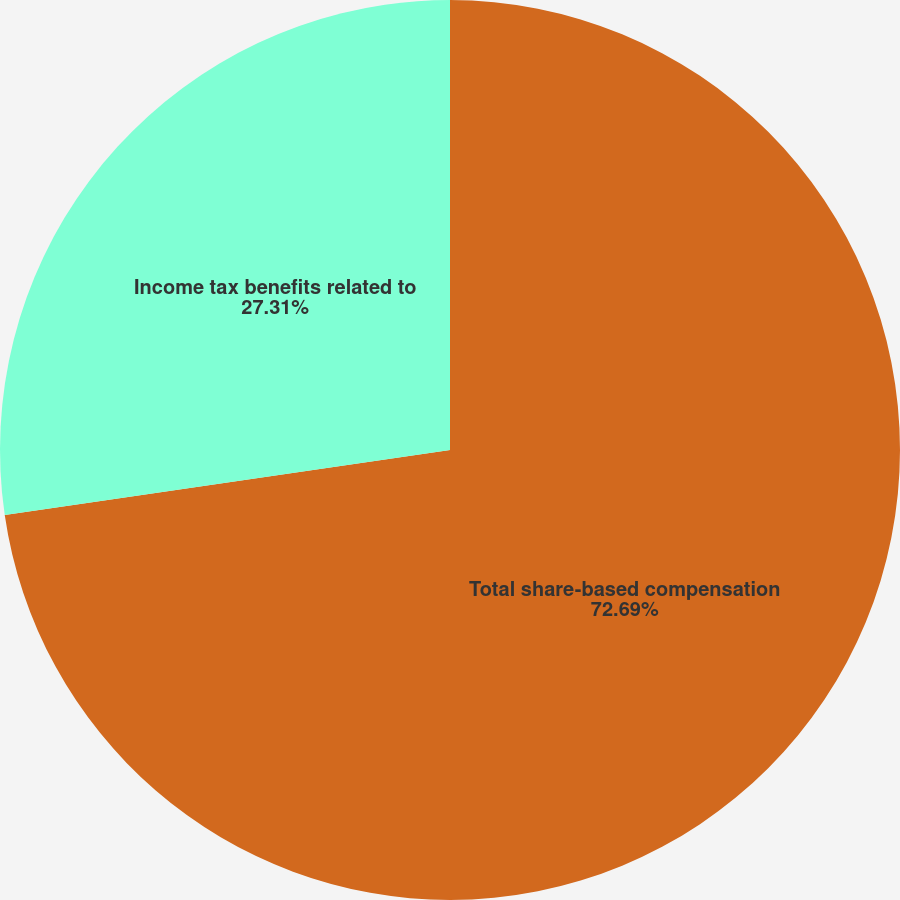Convert chart. <chart><loc_0><loc_0><loc_500><loc_500><pie_chart><fcel>Total share-based compensation<fcel>Income tax benefits related to<nl><fcel>72.69%<fcel>27.31%<nl></chart> 